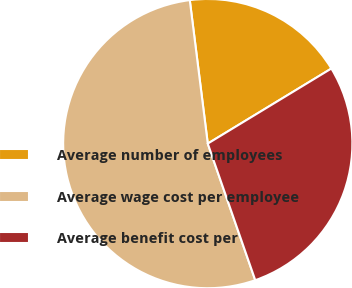Convert chart. <chart><loc_0><loc_0><loc_500><loc_500><pie_chart><fcel>Average number of employees<fcel>Average wage cost per employee<fcel>Average benefit cost per<nl><fcel>18.3%<fcel>53.34%<fcel>28.36%<nl></chart> 